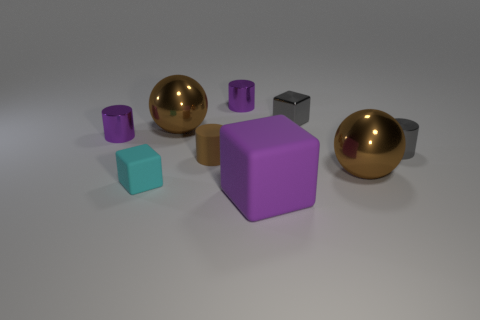Does the large purple thing have the same material as the small cyan cube?
Offer a terse response. Yes. Is there a big purple object of the same shape as the cyan thing?
Your answer should be very brief. Yes. Is the color of the ball to the right of the big purple block the same as the small metallic block?
Your answer should be compact. No. Does the brown ball on the left side of the small gray shiny block have the same size as the rubber object behind the tiny cyan thing?
Offer a terse response. No. There is a purple cube that is made of the same material as the tiny brown cylinder; what size is it?
Your response must be concise. Large. What number of tiny objects are left of the purple matte object and behind the small brown cylinder?
Give a very brief answer. 2. How many objects are gray metal blocks or cylinders on the left side of the cyan thing?
Provide a short and direct response. 2. The small thing that is the same color as the shiny block is what shape?
Provide a short and direct response. Cylinder. There is a large metallic thing in front of the gray metal cylinder; what color is it?
Offer a very short reply. Brown. How many objects are either cylinders to the right of the cyan rubber object or small purple cylinders?
Your response must be concise. 4. 